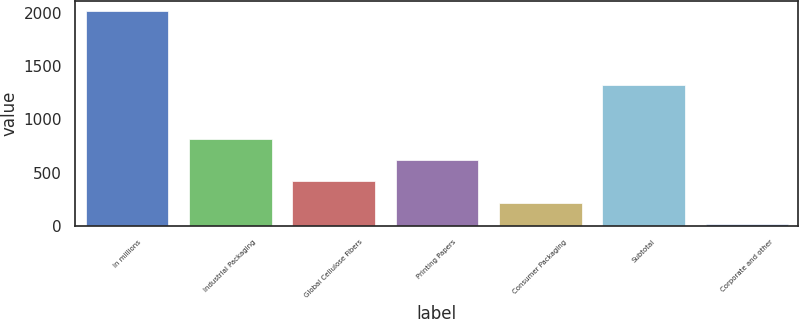Convert chart to OTSL. <chart><loc_0><loc_0><loc_500><loc_500><bar_chart><fcel>In millions<fcel>Industrial Packaging<fcel>Global Cellulose Fibers<fcel>Printing Papers<fcel>Consumer Packaging<fcel>Subtotal<fcel>Corporate and other<nl><fcel>2016<fcel>817.8<fcel>418.4<fcel>618.1<fcel>218.7<fcel>1329<fcel>19<nl></chart> 